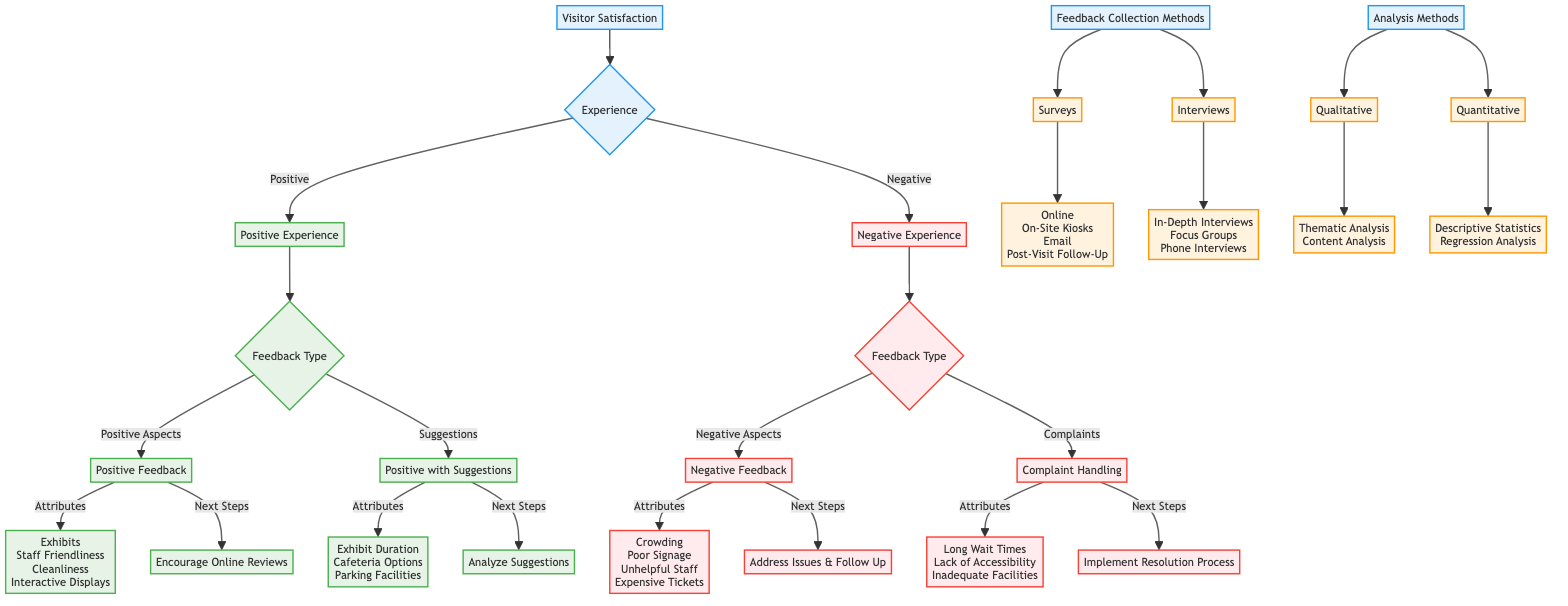What are the two types of visitor experiences? The diagram separates visitor experiences into two main categories: Positive and Negative.
Answer: Positive, Negative What attributes are listed under negative feedback? The diagram details four specific attributes associated with negative feedback: Crowding, Poor Signage, Unhelpful Staff, and Expensive Tickets.
Answer: Crowding, Poor Signage, Unhelpful Staff, Expensive Tickets What next step corresponds with positive feedback? The diagram indicates that the next step for positive feedback is to encourage visitors to leave positive reviews online.
Answer: Encourage Online Reviews How many feedback collection methods are identified? The diagram outlines two main feedback collection methods: Surveys and Interviews. Therefore, there are a total of two methods.
Answer: 2 What is the next step for complaints? The next step for handling complaints, according to the diagram, is to implement a resolution process and follow up with the visitor.
Answer: Implement Resolution Process What type of analysis is used for qualitative data? The diagram states that the types of analysis used for qualitative data include Thematic Analysis and Content Analysis.
Answer: Thematic Analysis, Content Analysis What feedback category includes suggestions for improvement? The diagram categorizes feedback with suggestions for improvement as "Positive with Suggestions."
Answer: Positive with Suggestions What are the channels listed for surveys? According to the diagram, the channels for surveys include Online, On-Site Kiosks, Email, and Post-Visit Follow-Up.
Answer: Online, On-Site Kiosks, Email, Post-Visit Follow-Up Which attributes require addressing specific issues? The diagram lists the attributes of negative aspects that require addressing specific issues as Crowding, Poor Signage, Unhelpful Staff, and Expensive Tickets.
Answer: Crowding, Poor Signage, Unhelpful Staff, Expensive Tickets 